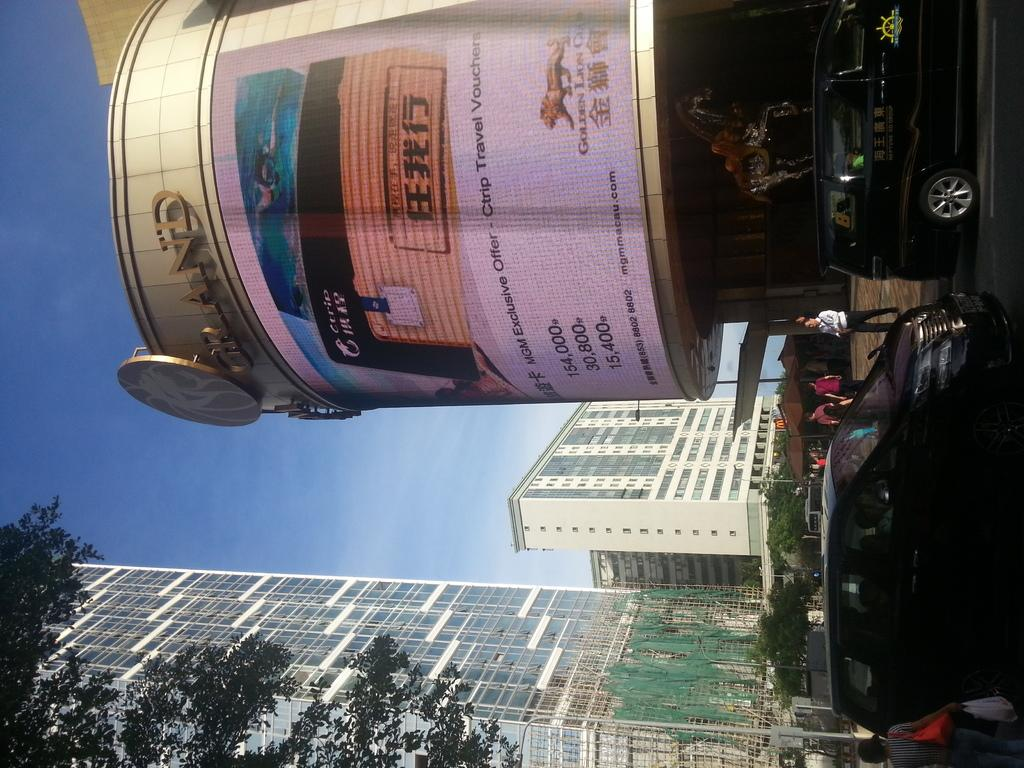What can be seen on the road in the image? There are cars on the road in the image. What are the people on the pavement doing? The people standing on the pavement are not engaged in any specific activity in the image. What can be seen in the background of the image? There are trees, buildings, and the sky visible in the background of the image. What type of prison can be seen in the image? There is no prison present in the image. What color is the skirt worn by the person on the pavement? There are no people wearing skirts in the image, as the people standing on the pavement are not engaged in any specific activity and their clothing is not visible. How is the glue being used in the image? There is no glue present in the image. 